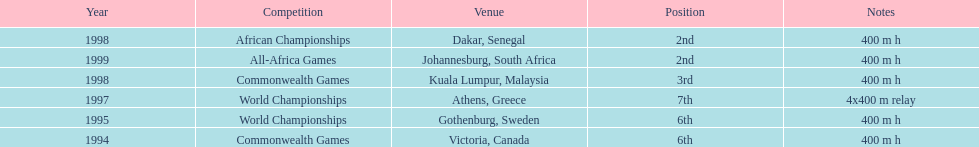In what years did ken harnden do better that 5th place? 1998, 1999. 